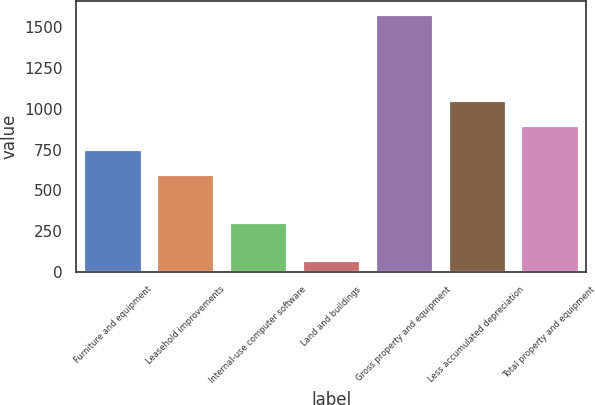Convert chart to OTSL. <chart><loc_0><loc_0><loc_500><loc_500><bar_chart><fcel>Furniture and equipment<fcel>Leasehold improvements<fcel>Internal-use computer software<fcel>Land and buildings<fcel>Gross property and equipment<fcel>Less accumulated depreciation<fcel>Total property and equipment<nl><fcel>750.85<fcel>599.8<fcel>306.5<fcel>73.1<fcel>1583.6<fcel>1052.95<fcel>901.9<nl></chart> 